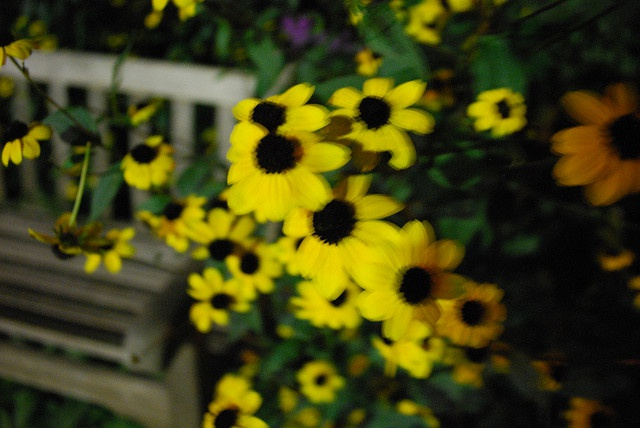Describe the objects in this image and their specific colors. I can see a bench in black, darkgreen, and gray tones in this image. 